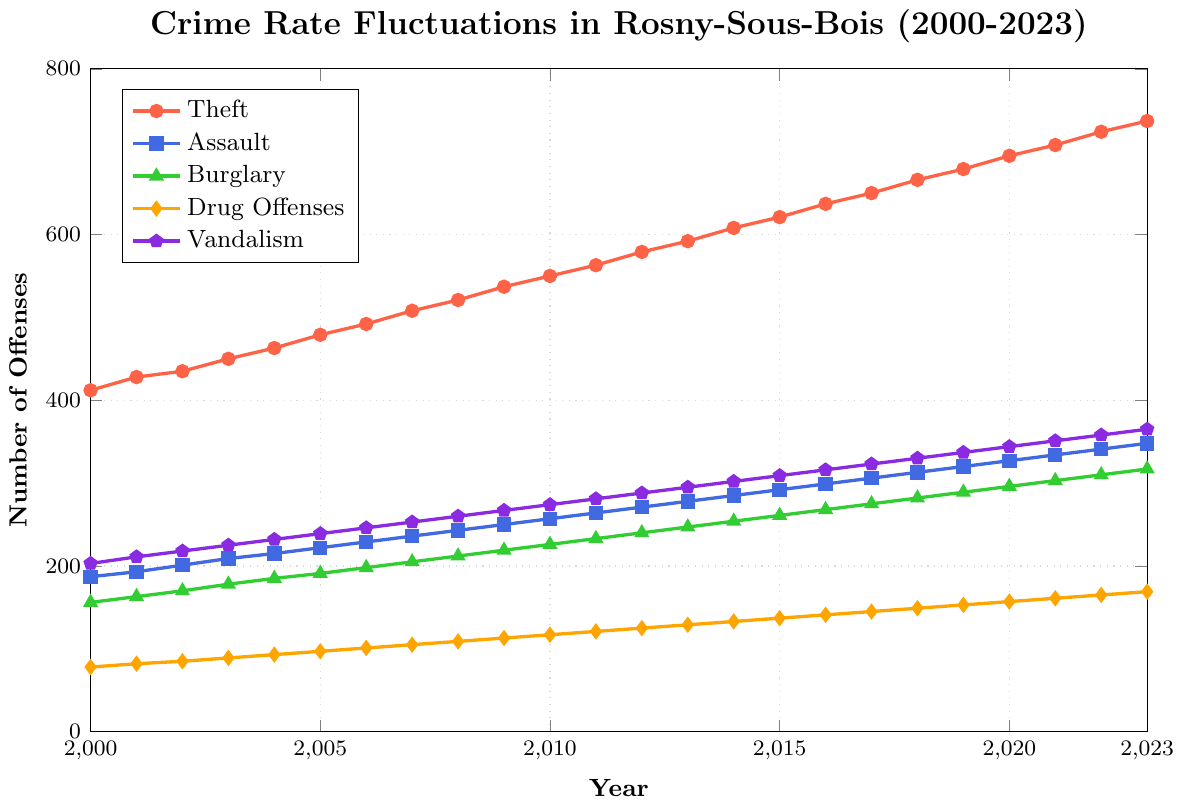What year did theft exceed 600 offenses for the first time? In the plot, tracing the 'Theft' line that crosses the 600 mark for the first time, you can see that it is in the year 2014.
Answer: 2014 Which type of offense had the smallest increase from 2000 to 2023? By comparing the overall increase for each offense type from 2000 to 2023: Theft (412 to 737), Assault (187 to 348), Burglary (156 to 317), Drug Offenses (78 to 169), and Vandalism (203 to 365). Drug Offenses had the smallest increase, which is 91.
Answer: Drug Offenses In what year did Vandalism surpass 300 offenses? By looking at the 'Vandalism' line, we identify where it surpasses the 300 mark, and it is in the year 2014.
Answer: 2014 Between 2010 and 2015, which type of offense saw the greatest rise in the number of offenses? From 2010 to 2015, we calculate the difference for each category: Theft (621 - 550 = 71), Assault (292 - 257 = 35), Burglary (261 - 226 = 35), Drug Offenses (137 - 117 = 20), Vandalism (309 - 274 = 35). Theft saw the greatest rise.
Answer: Theft What was the rate of increase in the number of Burglary offenses from 2000 to 2023? The rate of increase is calculated by finding the difference between the values for 2023 and 2000 and then dividing by the initial value. (317 - 156) / 156 ≈ 1.03, or 103%.
Answer: 103% Which offense type has the highest number in the year 2023? In the plot for the year 2023, comparing the numbers of different offenses: Theft (737), Assault (348), Burglary (317), Drug Offenses (169), and Vandalism (365). Theft has the highest number.
Answer: Theft In which year did Drug offenses reach or exceed 150 for the first time? Following the 'Drug Offenses' line, we find it reached the 150 mark in the year 2018.
Answer: 2018 How many more Assault offenses were there in 2023 compared to 2010? Subtract the number of Assault offenses in 2010 (257) from the number in 2023 (348): 348 - 257 = 91.
Answer: 91 Which year saw the smallest difference in offenses between Vandalism and Drug Offenses? By visually inspecting the gap between the 'Vandalism' (pentagon mark) and 'Drug Offenses' (diamond mark) lines for each year, the smallest difference occurs in 2000: Vandalism (203) - Drug Offenses (78) = 125.
Answer: 2000 